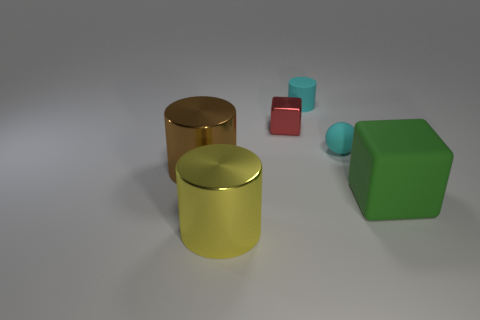Add 1 brown things. How many objects exist? 7 Subtract all cubes. How many objects are left? 4 Subtract all brown cylinders. Subtract all small rubber cylinders. How many objects are left? 4 Add 4 large green blocks. How many large green blocks are left? 5 Add 4 green cylinders. How many green cylinders exist? 4 Subtract 0 blue cylinders. How many objects are left? 6 